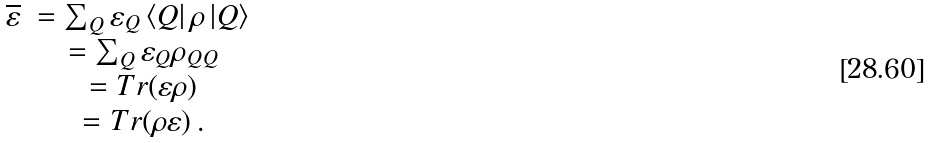Convert formula to latex. <formula><loc_0><loc_0><loc_500><loc_500>\begin{array} { c c } \overline { \varepsilon } & = \sum _ { Q } \varepsilon _ { Q } \left \langle Q \right | \rho \left | Q \right \rangle \\ & = \sum _ { Q } \varepsilon _ { Q } \rho _ { Q Q } \\ & = T r ( \varepsilon \rho ) \\ & = T r ( \rho \varepsilon ) \, . \end{array}</formula> 